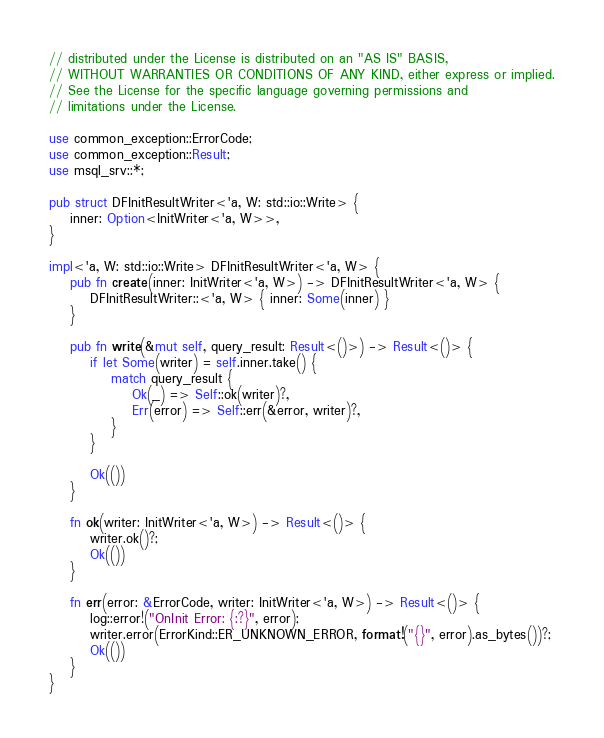<code> <loc_0><loc_0><loc_500><loc_500><_Rust_>// distributed under the License is distributed on an "AS IS" BASIS,
// WITHOUT WARRANTIES OR CONDITIONS OF ANY KIND, either express or implied.
// See the License for the specific language governing permissions and
// limitations under the License.

use common_exception::ErrorCode;
use common_exception::Result;
use msql_srv::*;

pub struct DFInitResultWriter<'a, W: std::io::Write> {
    inner: Option<InitWriter<'a, W>>,
}

impl<'a, W: std::io::Write> DFInitResultWriter<'a, W> {
    pub fn create(inner: InitWriter<'a, W>) -> DFInitResultWriter<'a, W> {
        DFInitResultWriter::<'a, W> { inner: Some(inner) }
    }

    pub fn write(&mut self, query_result: Result<()>) -> Result<()> {
        if let Some(writer) = self.inner.take() {
            match query_result {
                Ok(_) => Self::ok(writer)?,
                Err(error) => Self::err(&error, writer)?,
            }
        }

        Ok(())
    }

    fn ok(writer: InitWriter<'a, W>) -> Result<()> {
        writer.ok()?;
        Ok(())
    }

    fn err(error: &ErrorCode, writer: InitWriter<'a, W>) -> Result<()> {
        log::error!("OnInit Error: {:?}", error);
        writer.error(ErrorKind::ER_UNKNOWN_ERROR, format!("{}", error).as_bytes())?;
        Ok(())
    }
}
</code> 